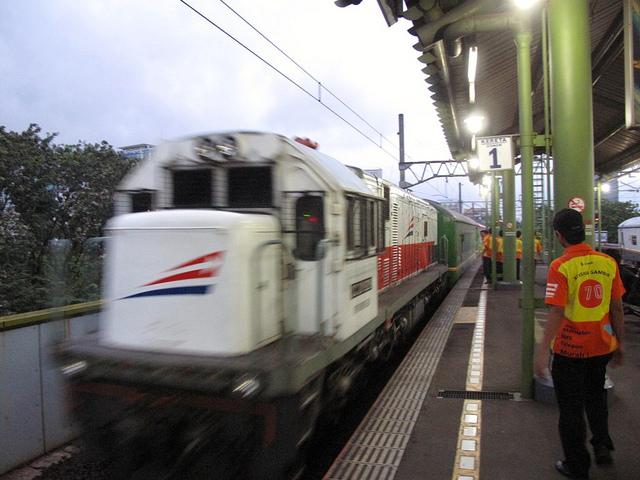Is the train moving fast?
Give a very brief answer. Yes. What color is the man's pants?
Be succinct. Black. Is the sun out?
Short answer required. Yes. What platform number is this?
Concise answer only. 1. Is this train in motion?
Answer briefly. Yes. Is this a high speed train?
Quick response, please. Yes. Is this a modern train?
Answer briefly. Yes. 